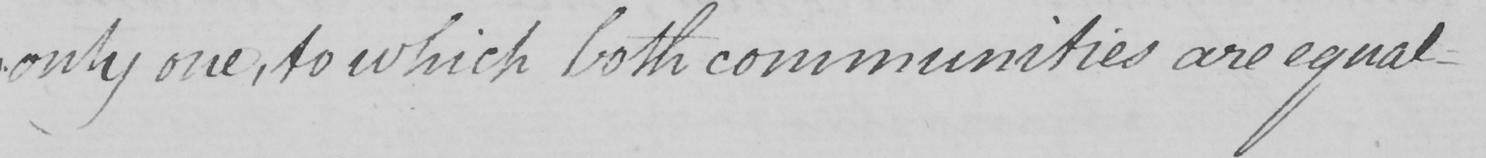What does this handwritten line say? " only one , to which both communities are equal- 